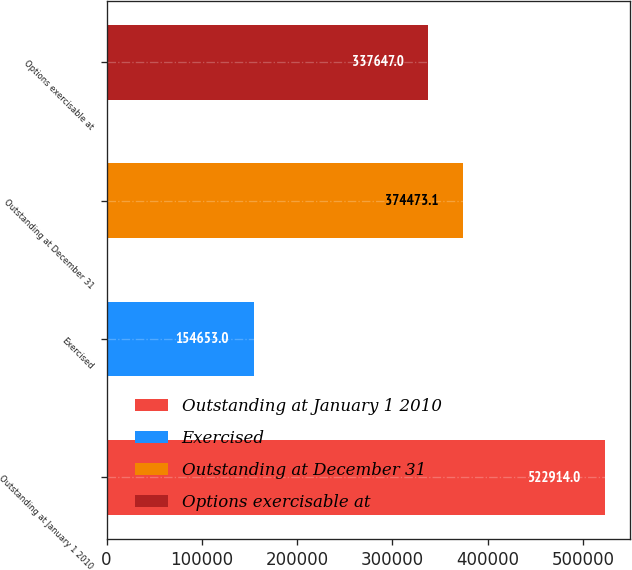Convert chart to OTSL. <chart><loc_0><loc_0><loc_500><loc_500><bar_chart><fcel>Outstanding at January 1 2010<fcel>Exercised<fcel>Outstanding at December 31<fcel>Options exercisable at<nl><fcel>522914<fcel>154653<fcel>374473<fcel>337647<nl></chart> 